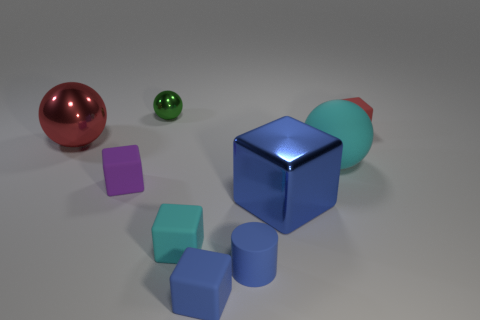Is there another blue block that has the same material as the big blue cube?
Your answer should be very brief. No. How many tiny things are both behind the cyan matte sphere and right of the green ball?
Keep it short and to the point. 1. Is the number of blue rubber cylinders in front of the red sphere less than the number of tiny rubber cylinders that are behind the tiny blue rubber cylinder?
Make the answer very short. No. Do the big red thing and the green metal object have the same shape?
Keep it short and to the point. Yes. What number of other objects are there of the same size as the rubber cylinder?
Your answer should be compact. 5. What number of objects are tiny matte things that are to the left of the big cyan ball or cubes that are on the right side of the big cyan object?
Your response must be concise. 5. What number of tiny metal objects are the same shape as the tiny cyan matte thing?
Your response must be concise. 0. What material is the thing that is left of the big cube and to the right of the small blue block?
Provide a succinct answer. Rubber. There is a large blue metallic object; what number of cyan matte spheres are on the left side of it?
Give a very brief answer. 0. What number of blue matte objects are there?
Offer a very short reply. 2. 